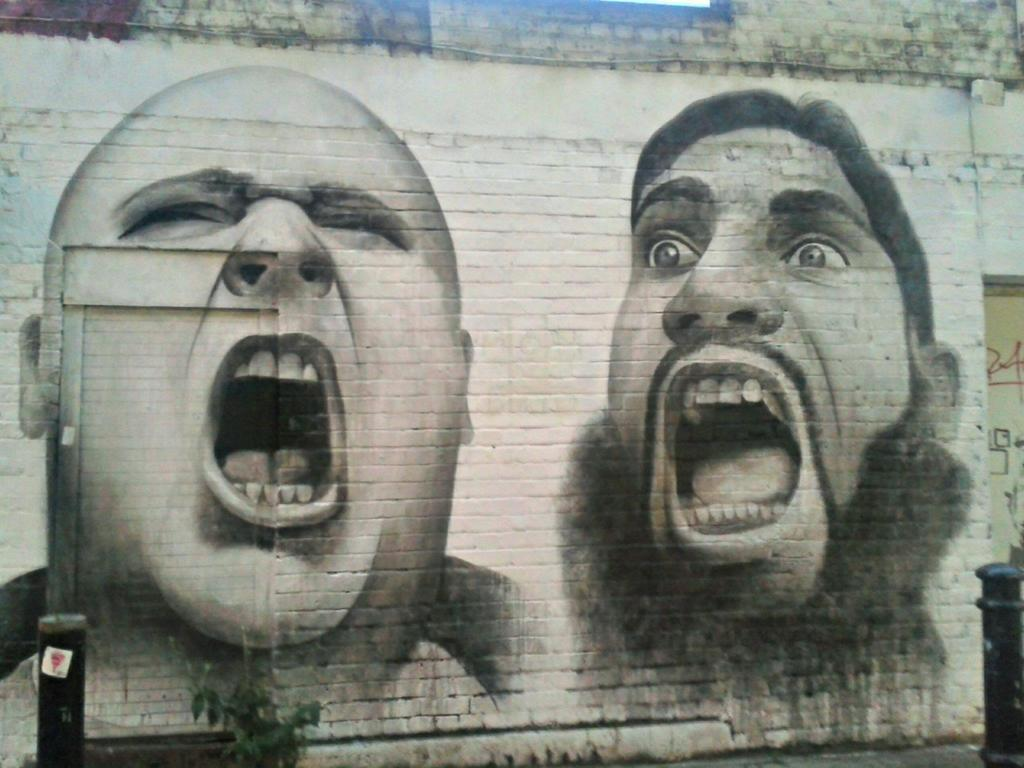What is depicted on the wall in the image? There is a painting of two persons' heads on the wall. What objects are in front of the wall? There are poles in front of the wall. Where is the cactus placed in the image? There is no cactus present in the image. 